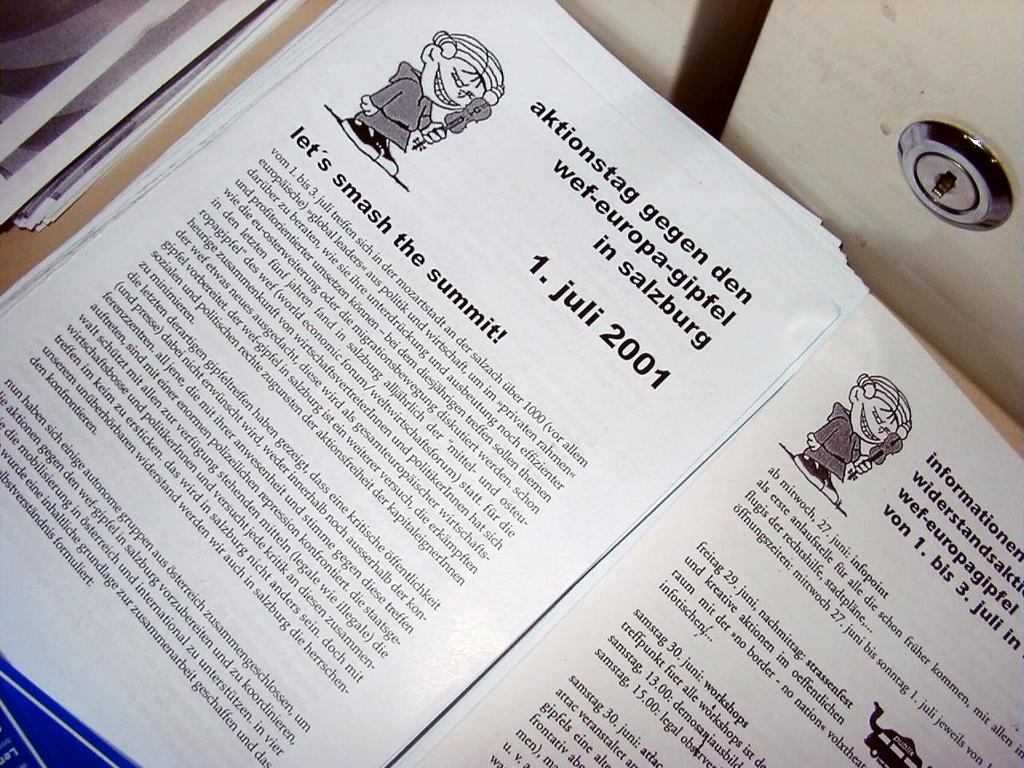<image>
Offer a succinct explanation of the picture presented. a paper that says 'smash the summit!' on it 